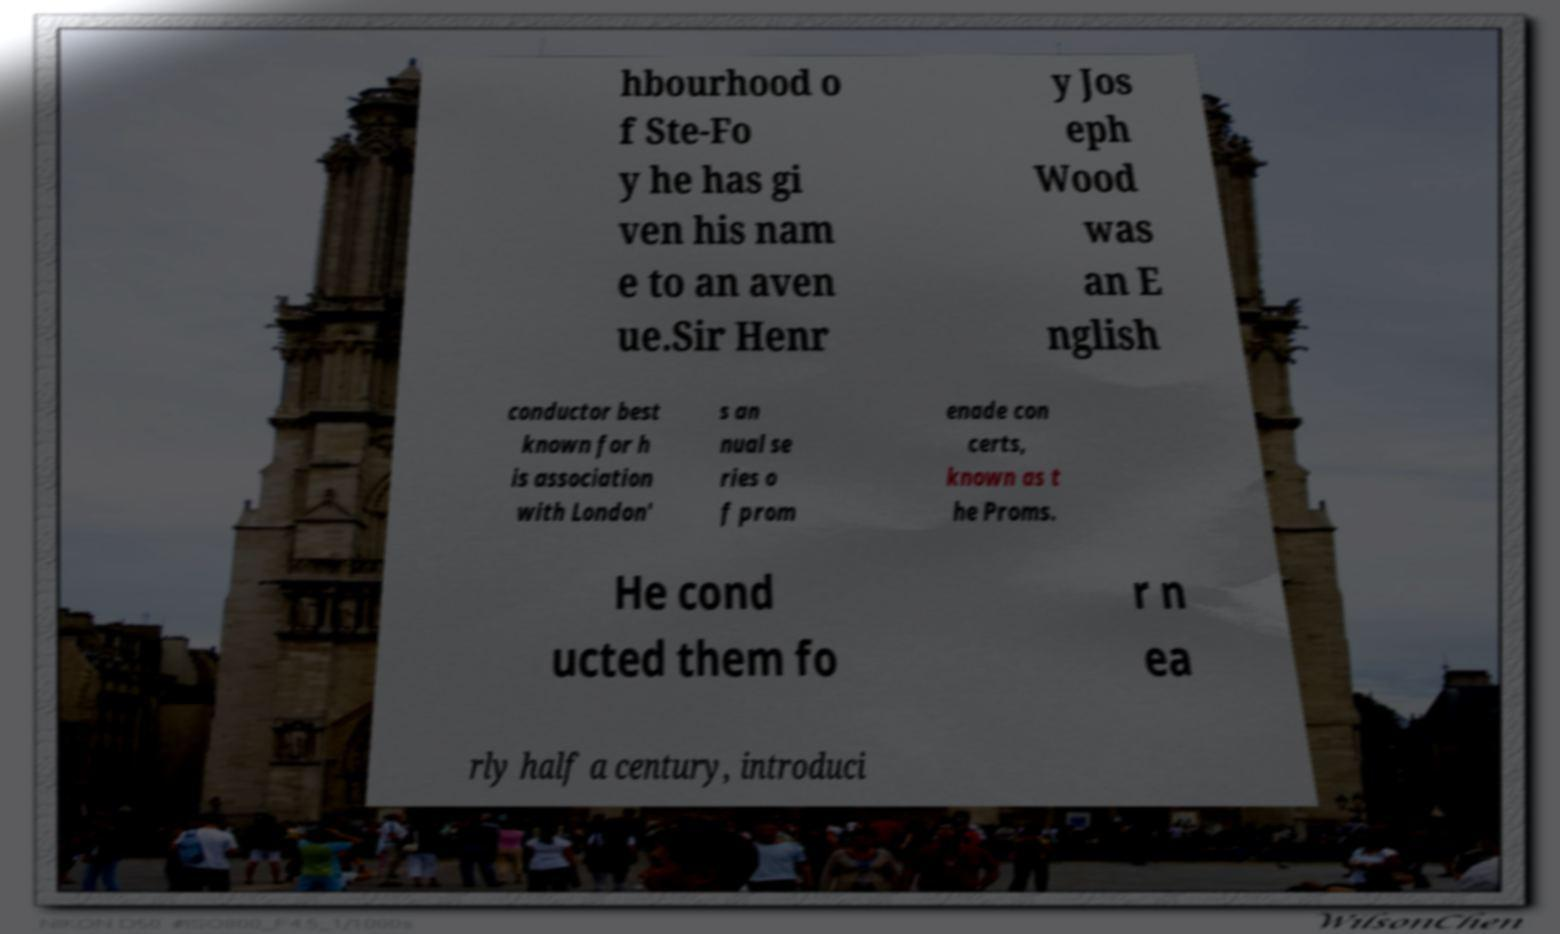For documentation purposes, I need the text within this image transcribed. Could you provide that? hbourhood o f Ste-Fo y he has gi ven his nam e to an aven ue.Sir Henr y Jos eph Wood was an E nglish conductor best known for h is association with London' s an nual se ries o f prom enade con certs, known as t he Proms. He cond ucted them fo r n ea rly half a century, introduci 